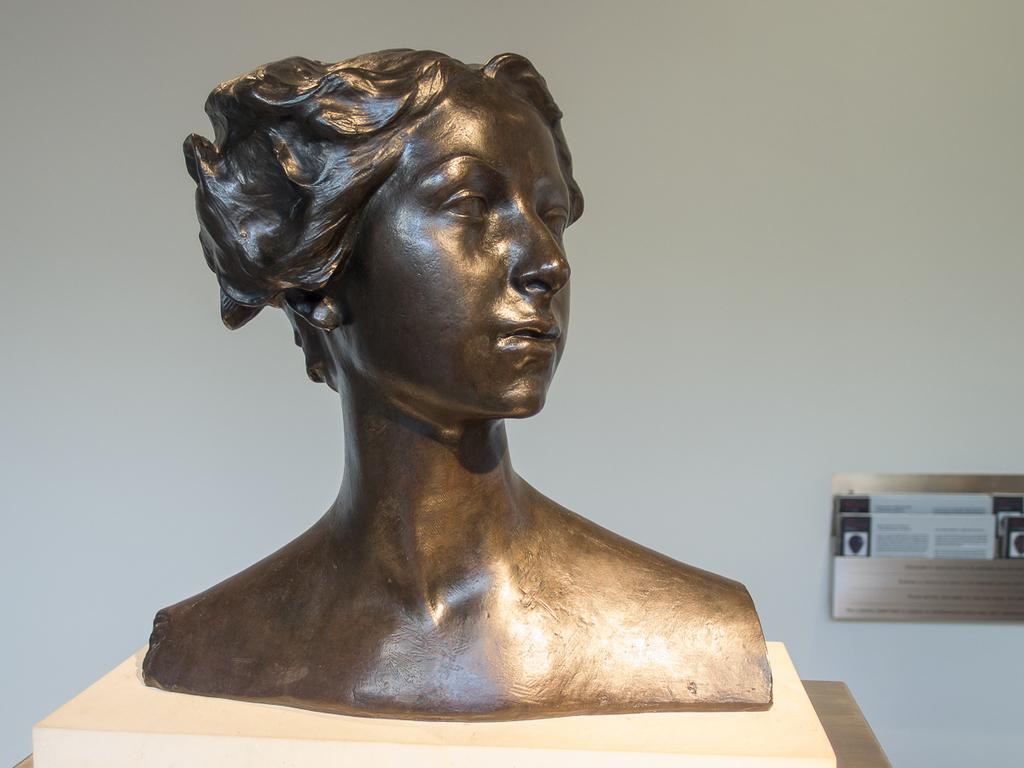What is the main subject in the image? There is a statue in the image. Where is the statue located? The statue is on a wooden table. What else can be seen in the image? There is a holder attached to the wall in the image. How many tomatoes are on the statue in the image? There are no tomatoes present in the image, as the focus is on the statue and the holder attached to the wall. 